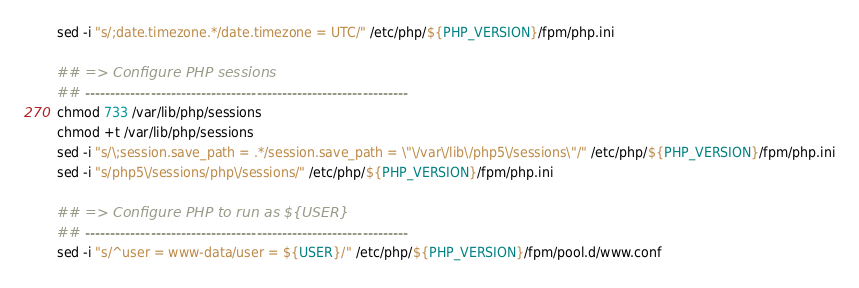<code> <loc_0><loc_0><loc_500><loc_500><_Bash_>sed -i "s/;date.timezone.*/date.timezone = UTC/" /etc/php/${PHP_VERSION}/fpm/php.ini

## => Configure PHP sessions
## ----------------------------------------------------------------
chmod 733 /var/lib/php/sessions
chmod +t /var/lib/php/sessions
sed -i "s/\;session.save_path = .*/session.save_path = \"\/var\/lib\/php5\/sessions\"/" /etc/php/${PHP_VERSION}/fpm/php.ini
sed -i "s/php5\/sessions/php\/sessions/" /etc/php/${PHP_VERSION}/fpm/php.ini

## => Configure PHP to run as ${USER}
## ----------------------------------------------------------------
sed -i "s/^user = www-data/user = ${USER}/" /etc/php/${PHP_VERSION}/fpm/pool.d/www.conf</code> 